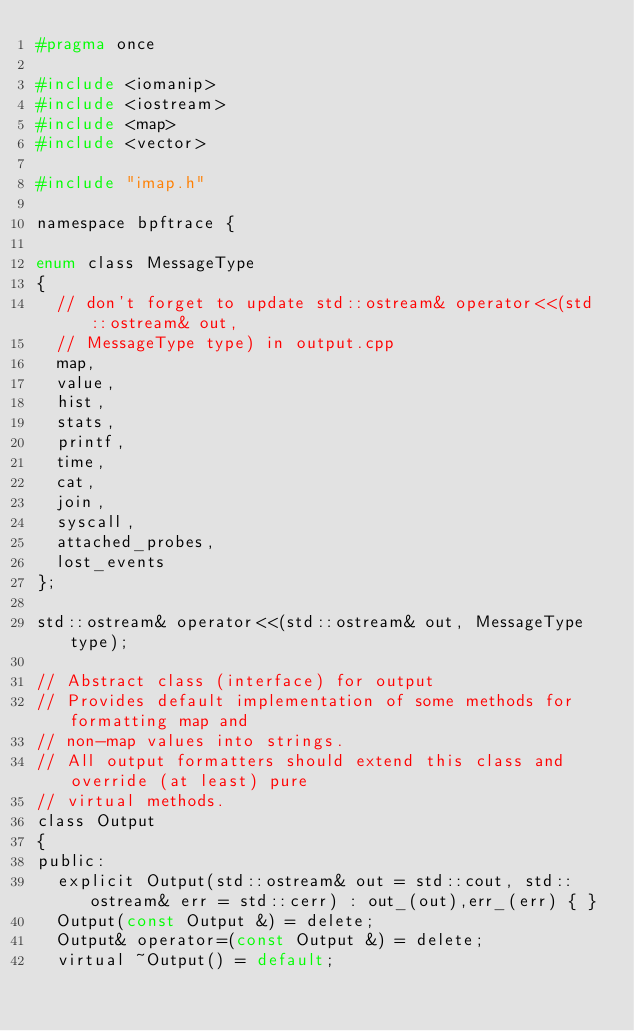Convert code to text. <code><loc_0><loc_0><loc_500><loc_500><_C_>#pragma once

#include <iomanip>
#include <iostream>
#include <map>
#include <vector>

#include "imap.h"

namespace bpftrace {

enum class MessageType
{
  // don't forget to update std::ostream& operator<<(std::ostream& out,
  // MessageType type) in output.cpp
  map,
  value,
  hist,
  stats,
  printf,
  time,
  cat,
  join,
  syscall,
  attached_probes,
  lost_events
};

std::ostream& operator<<(std::ostream& out, MessageType type);

// Abstract class (interface) for output
// Provides default implementation of some methods for formatting map and
// non-map values into strings.
// All output formatters should extend this class and override (at least) pure
// virtual methods.
class Output
{
public:
  explicit Output(std::ostream& out = std::cout, std::ostream& err = std::cerr) : out_(out),err_(err) { }
  Output(const Output &) = delete;
  Output& operator=(const Output &) = delete;
  virtual ~Output() = default;
</code> 